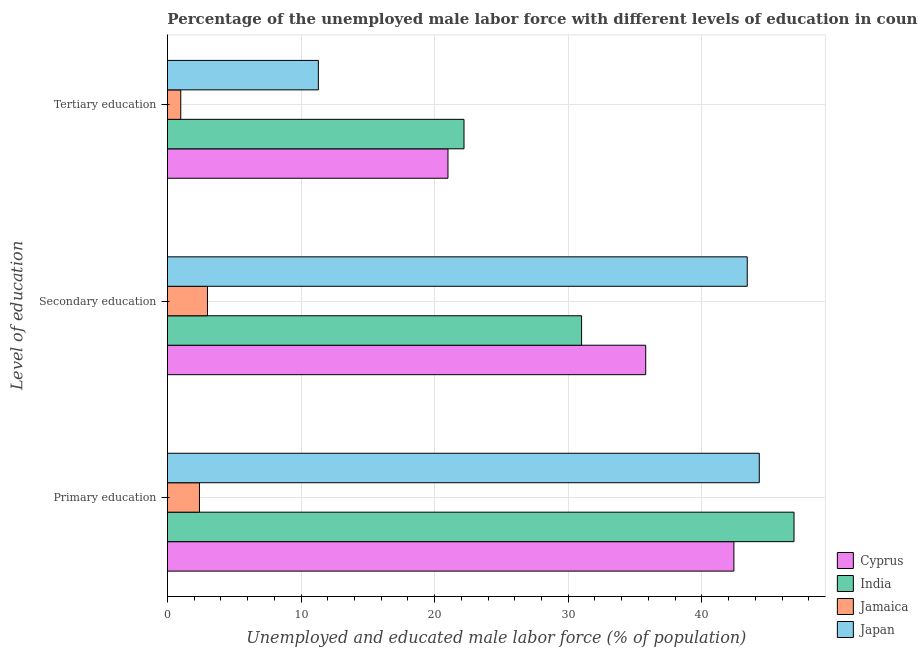Are the number of bars on each tick of the Y-axis equal?
Keep it short and to the point. Yes. How many bars are there on the 1st tick from the bottom?
Offer a very short reply. 4. What is the percentage of male labor force who received primary education in Japan?
Make the answer very short. 44.3. Across all countries, what is the maximum percentage of male labor force who received secondary education?
Ensure brevity in your answer.  43.4. Across all countries, what is the minimum percentage of male labor force who received tertiary education?
Keep it short and to the point. 1. In which country was the percentage of male labor force who received tertiary education minimum?
Your answer should be compact. Jamaica. What is the total percentage of male labor force who received tertiary education in the graph?
Provide a succinct answer. 55.5. What is the difference between the percentage of male labor force who received primary education in India and that in Japan?
Provide a succinct answer. 2.6. What is the difference between the percentage of male labor force who received primary education in Jamaica and the percentage of male labor force who received secondary education in Japan?
Provide a short and direct response. -41. What is the average percentage of male labor force who received primary education per country?
Offer a very short reply. 34. What is the difference between the percentage of male labor force who received primary education and percentage of male labor force who received tertiary education in Jamaica?
Keep it short and to the point. 1.4. In how many countries, is the percentage of male labor force who received secondary education greater than 10 %?
Ensure brevity in your answer.  3. What is the ratio of the percentage of male labor force who received primary education in India to that in Cyprus?
Your response must be concise. 1.11. Is the percentage of male labor force who received tertiary education in Jamaica less than that in Cyprus?
Make the answer very short. Yes. What is the difference between the highest and the second highest percentage of male labor force who received tertiary education?
Make the answer very short. 1.2. What is the difference between the highest and the lowest percentage of male labor force who received tertiary education?
Provide a succinct answer. 21.2. What does the 1st bar from the top in Primary education represents?
Offer a very short reply. Japan. What does the 4th bar from the bottom in Tertiary education represents?
Give a very brief answer. Japan. Is it the case that in every country, the sum of the percentage of male labor force who received primary education and percentage of male labor force who received secondary education is greater than the percentage of male labor force who received tertiary education?
Your response must be concise. Yes. Does the graph contain any zero values?
Ensure brevity in your answer.  No. Where does the legend appear in the graph?
Ensure brevity in your answer.  Bottom right. What is the title of the graph?
Give a very brief answer. Percentage of the unemployed male labor force with different levels of education in countries. What is the label or title of the X-axis?
Provide a short and direct response. Unemployed and educated male labor force (% of population). What is the label or title of the Y-axis?
Make the answer very short. Level of education. What is the Unemployed and educated male labor force (% of population) of Cyprus in Primary education?
Provide a short and direct response. 42.4. What is the Unemployed and educated male labor force (% of population) of India in Primary education?
Offer a terse response. 46.9. What is the Unemployed and educated male labor force (% of population) in Jamaica in Primary education?
Your answer should be very brief. 2.4. What is the Unemployed and educated male labor force (% of population) of Japan in Primary education?
Keep it short and to the point. 44.3. What is the Unemployed and educated male labor force (% of population) of Cyprus in Secondary education?
Give a very brief answer. 35.8. What is the Unemployed and educated male labor force (% of population) in India in Secondary education?
Your response must be concise. 31. What is the Unemployed and educated male labor force (% of population) in Jamaica in Secondary education?
Your answer should be compact. 3. What is the Unemployed and educated male labor force (% of population) in Japan in Secondary education?
Your answer should be very brief. 43.4. What is the Unemployed and educated male labor force (% of population) of India in Tertiary education?
Offer a terse response. 22.2. What is the Unemployed and educated male labor force (% of population) of Jamaica in Tertiary education?
Your answer should be compact. 1. What is the Unemployed and educated male labor force (% of population) of Japan in Tertiary education?
Give a very brief answer. 11.3. Across all Level of education, what is the maximum Unemployed and educated male labor force (% of population) of Cyprus?
Ensure brevity in your answer.  42.4. Across all Level of education, what is the maximum Unemployed and educated male labor force (% of population) of India?
Offer a terse response. 46.9. Across all Level of education, what is the maximum Unemployed and educated male labor force (% of population) of Japan?
Offer a terse response. 44.3. Across all Level of education, what is the minimum Unemployed and educated male labor force (% of population) in India?
Offer a very short reply. 22.2. Across all Level of education, what is the minimum Unemployed and educated male labor force (% of population) of Japan?
Keep it short and to the point. 11.3. What is the total Unemployed and educated male labor force (% of population) in Cyprus in the graph?
Your answer should be compact. 99.2. What is the total Unemployed and educated male labor force (% of population) in India in the graph?
Keep it short and to the point. 100.1. What is the difference between the Unemployed and educated male labor force (% of population) of Cyprus in Primary education and that in Secondary education?
Offer a terse response. 6.6. What is the difference between the Unemployed and educated male labor force (% of population) of Jamaica in Primary education and that in Secondary education?
Your response must be concise. -0.6. What is the difference between the Unemployed and educated male labor force (% of population) of Japan in Primary education and that in Secondary education?
Offer a terse response. 0.9. What is the difference between the Unemployed and educated male labor force (% of population) of Cyprus in Primary education and that in Tertiary education?
Your response must be concise. 21.4. What is the difference between the Unemployed and educated male labor force (% of population) of India in Primary education and that in Tertiary education?
Your answer should be very brief. 24.7. What is the difference between the Unemployed and educated male labor force (% of population) of Japan in Secondary education and that in Tertiary education?
Make the answer very short. 32.1. What is the difference between the Unemployed and educated male labor force (% of population) in Cyprus in Primary education and the Unemployed and educated male labor force (% of population) in India in Secondary education?
Make the answer very short. 11.4. What is the difference between the Unemployed and educated male labor force (% of population) of Cyprus in Primary education and the Unemployed and educated male labor force (% of population) of Jamaica in Secondary education?
Your answer should be very brief. 39.4. What is the difference between the Unemployed and educated male labor force (% of population) in India in Primary education and the Unemployed and educated male labor force (% of population) in Jamaica in Secondary education?
Provide a short and direct response. 43.9. What is the difference between the Unemployed and educated male labor force (% of population) of Jamaica in Primary education and the Unemployed and educated male labor force (% of population) of Japan in Secondary education?
Your response must be concise. -41. What is the difference between the Unemployed and educated male labor force (% of population) of Cyprus in Primary education and the Unemployed and educated male labor force (% of population) of India in Tertiary education?
Offer a very short reply. 20.2. What is the difference between the Unemployed and educated male labor force (% of population) of Cyprus in Primary education and the Unemployed and educated male labor force (% of population) of Jamaica in Tertiary education?
Ensure brevity in your answer.  41.4. What is the difference between the Unemployed and educated male labor force (% of population) in Cyprus in Primary education and the Unemployed and educated male labor force (% of population) in Japan in Tertiary education?
Keep it short and to the point. 31.1. What is the difference between the Unemployed and educated male labor force (% of population) in India in Primary education and the Unemployed and educated male labor force (% of population) in Jamaica in Tertiary education?
Keep it short and to the point. 45.9. What is the difference between the Unemployed and educated male labor force (% of population) in India in Primary education and the Unemployed and educated male labor force (% of population) in Japan in Tertiary education?
Give a very brief answer. 35.6. What is the difference between the Unemployed and educated male labor force (% of population) in Cyprus in Secondary education and the Unemployed and educated male labor force (% of population) in India in Tertiary education?
Make the answer very short. 13.6. What is the difference between the Unemployed and educated male labor force (% of population) of Cyprus in Secondary education and the Unemployed and educated male labor force (% of population) of Jamaica in Tertiary education?
Your answer should be very brief. 34.8. What is the difference between the Unemployed and educated male labor force (% of population) in India in Secondary education and the Unemployed and educated male labor force (% of population) in Jamaica in Tertiary education?
Make the answer very short. 30. What is the difference between the Unemployed and educated male labor force (% of population) of India in Secondary education and the Unemployed and educated male labor force (% of population) of Japan in Tertiary education?
Make the answer very short. 19.7. What is the average Unemployed and educated male labor force (% of population) in Cyprus per Level of education?
Make the answer very short. 33.07. What is the average Unemployed and educated male labor force (% of population) in India per Level of education?
Give a very brief answer. 33.37. What is the average Unemployed and educated male labor force (% of population) of Jamaica per Level of education?
Offer a very short reply. 2.13. What is the difference between the Unemployed and educated male labor force (% of population) in Cyprus and Unemployed and educated male labor force (% of population) in Jamaica in Primary education?
Keep it short and to the point. 40. What is the difference between the Unemployed and educated male labor force (% of population) in India and Unemployed and educated male labor force (% of population) in Jamaica in Primary education?
Offer a terse response. 44.5. What is the difference between the Unemployed and educated male labor force (% of population) of India and Unemployed and educated male labor force (% of population) of Japan in Primary education?
Provide a succinct answer. 2.6. What is the difference between the Unemployed and educated male labor force (% of population) in Jamaica and Unemployed and educated male labor force (% of population) in Japan in Primary education?
Your response must be concise. -41.9. What is the difference between the Unemployed and educated male labor force (% of population) of Cyprus and Unemployed and educated male labor force (% of population) of India in Secondary education?
Make the answer very short. 4.8. What is the difference between the Unemployed and educated male labor force (% of population) of Cyprus and Unemployed and educated male labor force (% of population) of Jamaica in Secondary education?
Your answer should be very brief. 32.8. What is the difference between the Unemployed and educated male labor force (% of population) of Cyprus and Unemployed and educated male labor force (% of population) of Japan in Secondary education?
Make the answer very short. -7.6. What is the difference between the Unemployed and educated male labor force (% of population) in India and Unemployed and educated male labor force (% of population) in Jamaica in Secondary education?
Offer a terse response. 28. What is the difference between the Unemployed and educated male labor force (% of population) of Jamaica and Unemployed and educated male labor force (% of population) of Japan in Secondary education?
Your answer should be compact. -40.4. What is the difference between the Unemployed and educated male labor force (% of population) in Cyprus and Unemployed and educated male labor force (% of population) in Jamaica in Tertiary education?
Provide a succinct answer. 20. What is the difference between the Unemployed and educated male labor force (% of population) in Cyprus and Unemployed and educated male labor force (% of population) in Japan in Tertiary education?
Provide a short and direct response. 9.7. What is the difference between the Unemployed and educated male labor force (% of population) in India and Unemployed and educated male labor force (% of population) in Jamaica in Tertiary education?
Your response must be concise. 21.2. What is the difference between the Unemployed and educated male labor force (% of population) in India and Unemployed and educated male labor force (% of population) in Japan in Tertiary education?
Your response must be concise. 10.9. What is the difference between the Unemployed and educated male labor force (% of population) of Jamaica and Unemployed and educated male labor force (% of population) of Japan in Tertiary education?
Keep it short and to the point. -10.3. What is the ratio of the Unemployed and educated male labor force (% of population) of Cyprus in Primary education to that in Secondary education?
Give a very brief answer. 1.18. What is the ratio of the Unemployed and educated male labor force (% of population) of India in Primary education to that in Secondary education?
Ensure brevity in your answer.  1.51. What is the ratio of the Unemployed and educated male labor force (% of population) in Jamaica in Primary education to that in Secondary education?
Offer a terse response. 0.8. What is the ratio of the Unemployed and educated male labor force (% of population) of Japan in Primary education to that in Secondary education?
Offer a terse response. 1.02. What is the ratio of the Unemployed and educated male labor force (% of population) of Cyprus in Primary education to that in Tertiary education?
Give a very brief answer. 2.02. What is the ratio of the Unemployed and educated male labor force (% of population) in India in Primary education to that in Tertiary education?
Provide a succinct answer. 2.11. What is the ratio of the Unemployed and educated male labor force (% of population) of Japan in Primary education to that in Tertiary education?
Give a very brief answer. 3.92. What is the ratio of the Unemployed and educated male labor force (% of population) of Cyprus in Secondary education to that in Tertiary education?
Ensure brevity in your answer.  1.7. What is the ratio of the Unemployed and educated male labor force (% of population) in India in Secondary education to that in Tertiary education?
Give a very brief answer. 1.4. What is the ratio of the Unemployed and educated male labor force (% of population) of Japan in Secondary education to that in Tertiary education?
Provide a short and direct response. 3.84. What is the difference between the highest and the second highest Unemployed and educated male labor force (% of population) in Cyprus?
Your response must be concise. 6.6. What is the difference between the highest and the second highest Unemployed and educated male labor force (% of population) of India?
Make the answer very short. 15.9. What is the difference between the highest and the second highest Unemployed and educated male labor force (% of population) in Jamaica?
Your response must be concise. 0.6. What is the difference between the highest and the second highest Unemployed and educated male labor force (% of population) of Japan?
Your answer should be compact. 0.9. What is the difference between the highest and the lowest Unemployed and educated male labor force (% of population) of Cyprus?
Your answer should be very brief. 21.4. What is the difference between the highest and the lowest Unemployed and educated male labor force (% of population) in India?
Your answer should be compact. 24.7. What is the difference between the highest and the lowest Unemployed and educated male labor force (% of population) of Jamaica?
Provide a succinct answer. 2. What is the difference between the highest and the lowest Unemployed and educated male labor force (% of population) of Japan?
Offer a terse response. 33. 